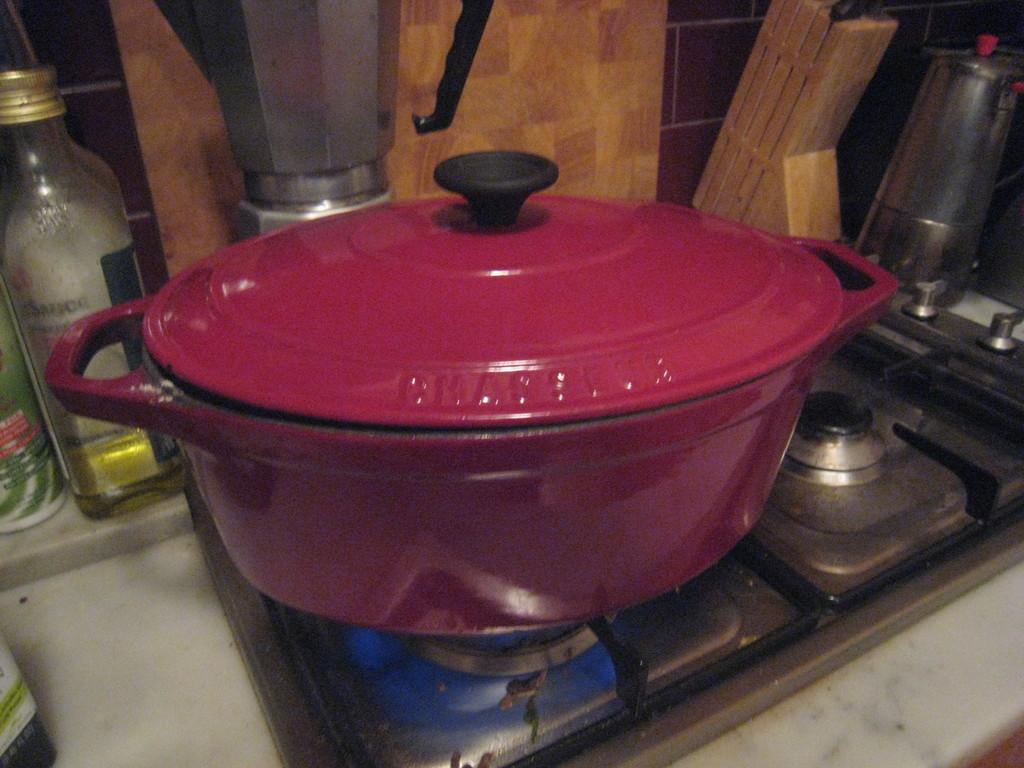What color is the dish in the image? The dish in the image is maroon. Where is the dish located in the image? The dish is on a gas stove. What other items can be seen in the background of the image? There is a bottle, a mixer, a wooden object, and a steel jug in the background of the image. What type of pain is being expressed by the dish in the image? The dish in the image is an inanimate object and cannot express pain. 